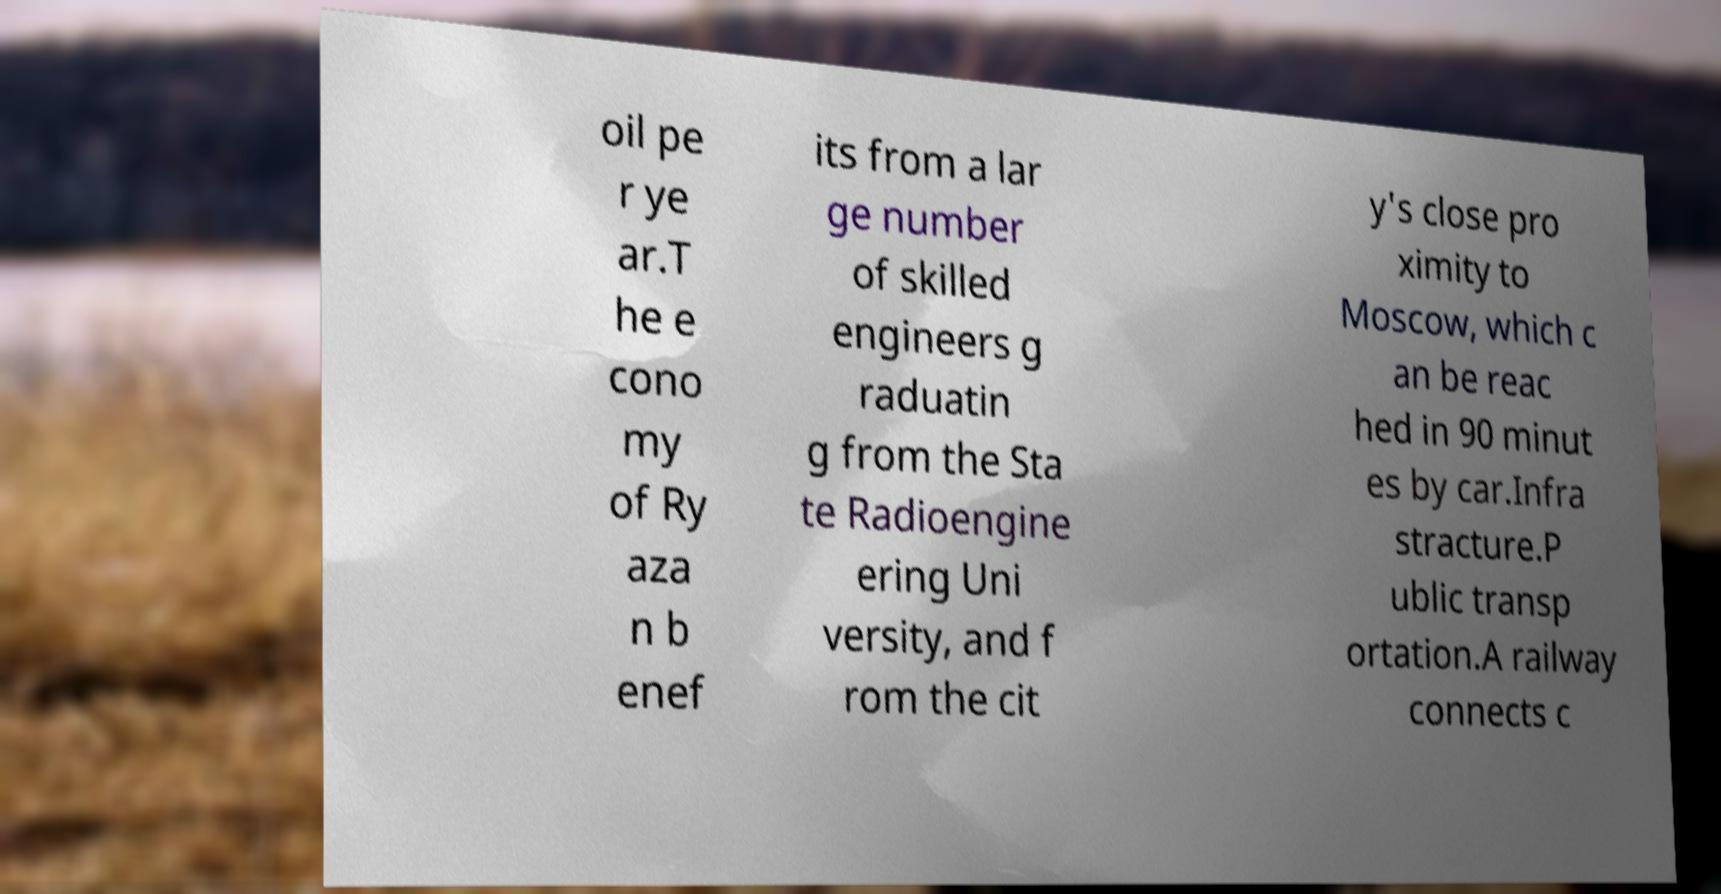Could you extract and type out the text from this image? oil pe r ye ar.T he e cono my of Ry aza n b enef its from a lar ge number of skilled engineers g raduatin g from the Sta te Radioengine ering Uni versity, and f rom the cit y's close pro ximity to Moscow, which c an be reac hed in 90 minut es by car.Infra stracture.P ublic transp ortation.A railway connects c 